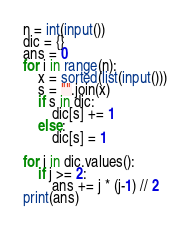Convert code to text. <code><loc_0><loc_0><loc_500><loc_500><_Python_>n = int(input())
dic = {}
ans = 0
for i in range(n):
    x = sorted(list(input()))
    s = "".join(x)
    if s in dic:
        dic[s] += 1
    else:
        dic[s] = 1
        
for j in dic.values():
    if j >= 2:
        ans += j * (j-1) // 2
print(ans)</code> 